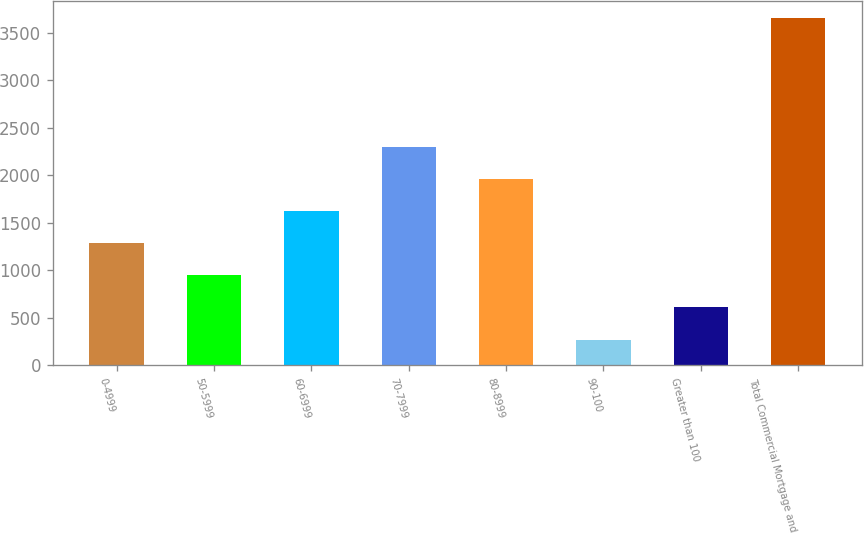Convert chart to OTSL. <chart><loc_0><loc_0><loc_500><loc_500><bar_chart><fcel>0-4999<fcel>50-5999<fcel>60-6999<fcel>70-7999<fcel>80-8999<fcel>90-100<fcel>Greater than 100<fcel>Total Commercial Mortgage and<nl><fcel>1284<fcel>946<fcel>1622<fcel>2298<fcel>1960<fcel>270<fcel>608<fcel>3650<nl></chart> 